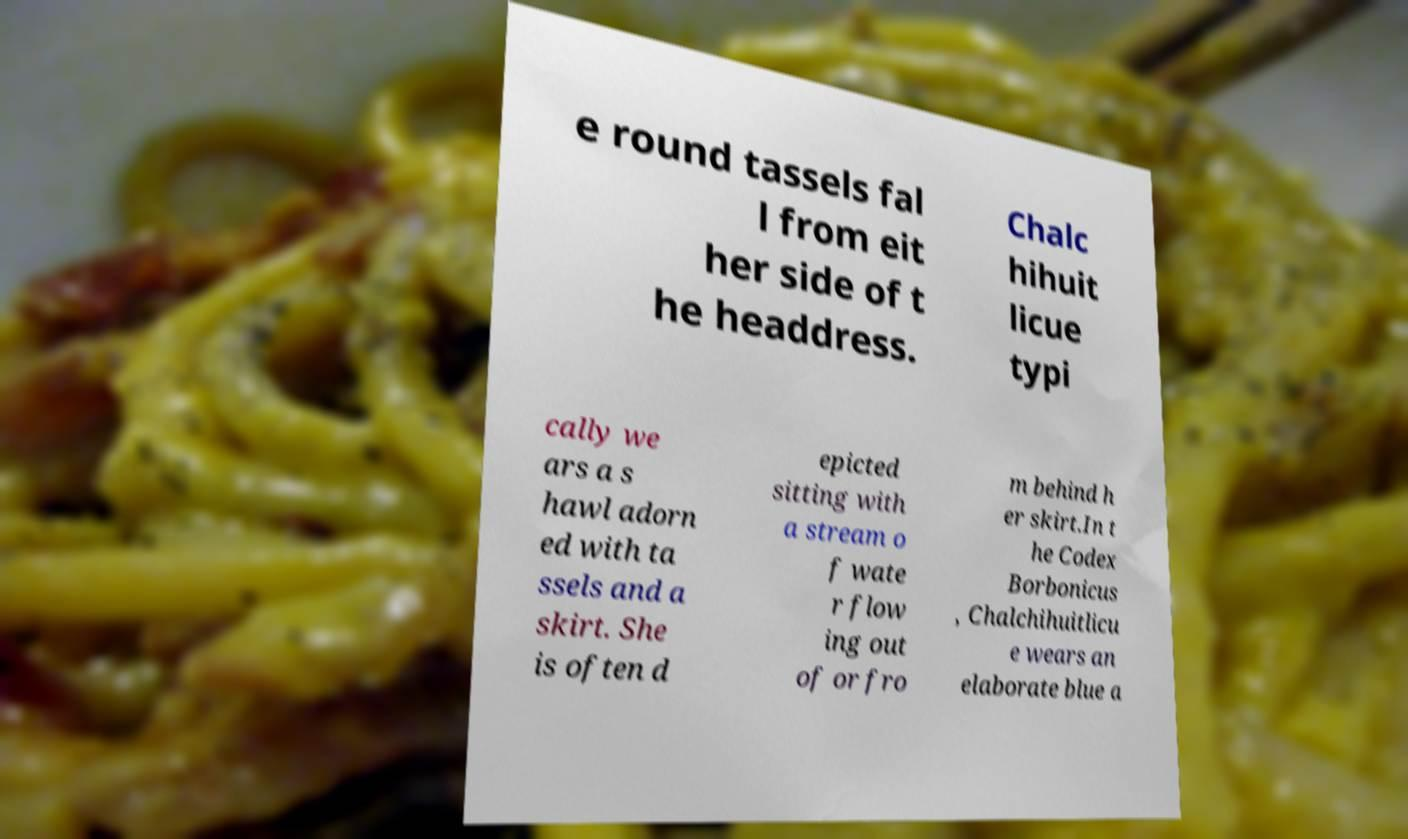What messages or text are displayed in this image? I need them in a readable, typed format. e round tassels fal l from eit her side of t he headdress. Chalc hihuit licue typi cally we ars a s hawl adorn ed with ta ssels and a skirt. She is often d epicted sitting with a stream o f wate r flow ing out of or fro m behind h er skirt.In t he Codex Borbonicus , Chalchihuitlicu e wears an elaborate blue a 